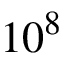Convert formula to latex. <formula><loc_0><loc_0><loc_500><loc_500>1 0 ^ { 8 }</formula> 